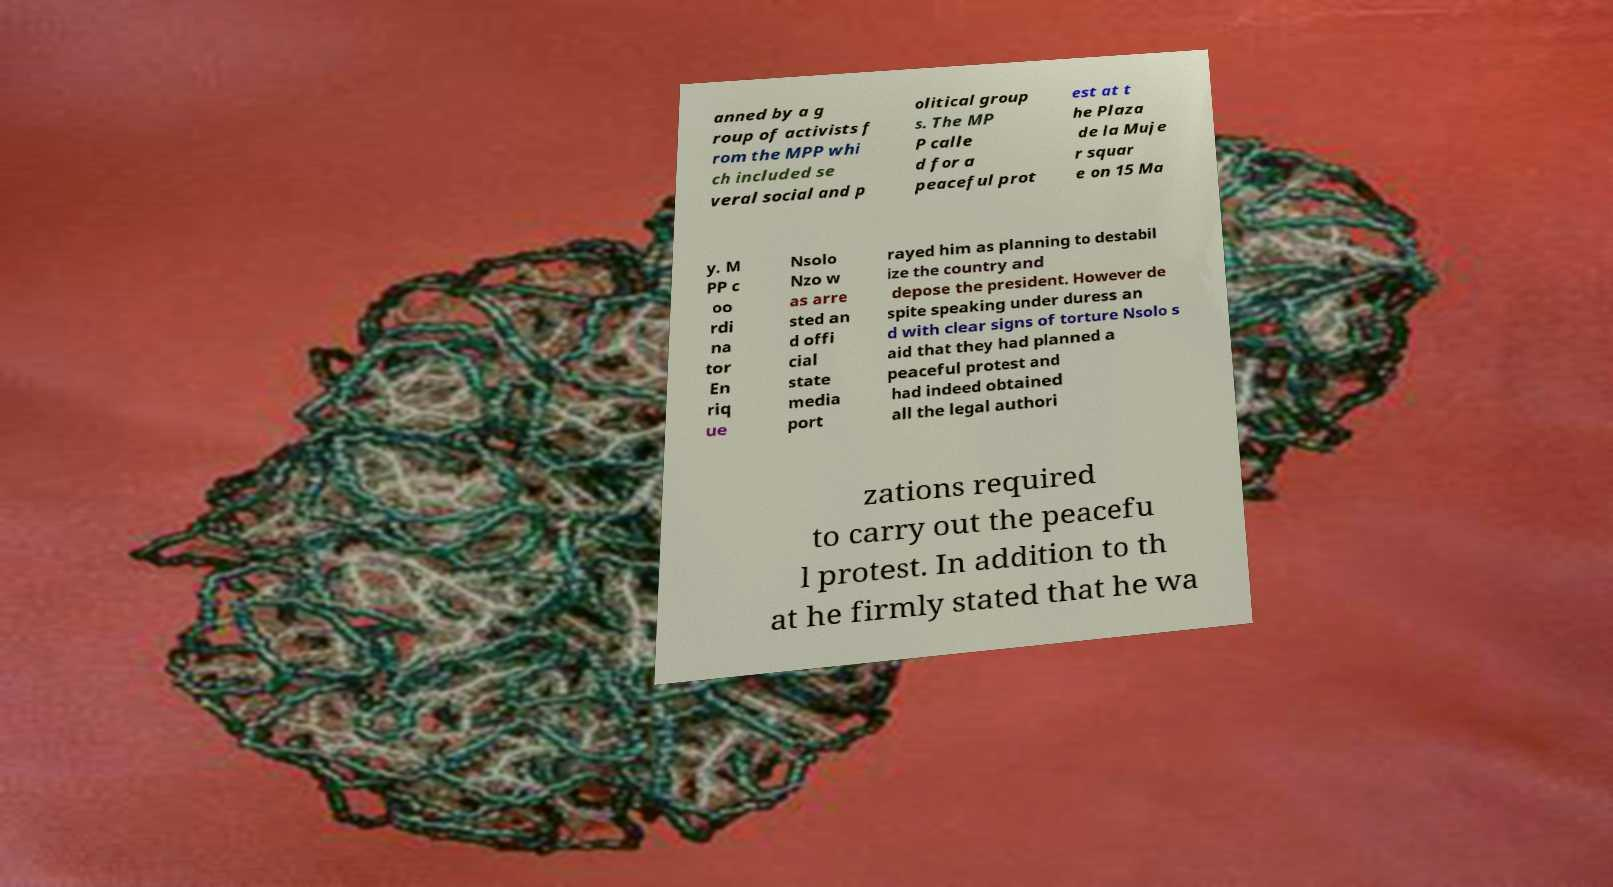Can you read and provide the text displayed in the image?This photo seems to have some interesting text. Can you extract and type it out for me? anned by a g roup of activists f rom the MPP whi ch included se veral social and p olitical group s. The MP P calle d for a peaceful prot est at t he Plaza de la Muje r squar e on 15 Ma y. M PP c oo rdi na tor En riq ue Nsolo Nzo w as arre sted an d offi cial state media port rayed him as planning to destabil ize the country and depose the president. However de spite speaking under duress an d with clear signs of torture Nsolo s aid that they had planned a peaceful protest and had indeed obtained all the legal authori zations required to carry out the peacefu l protest. In addition to th at he firmly stated that he wa 